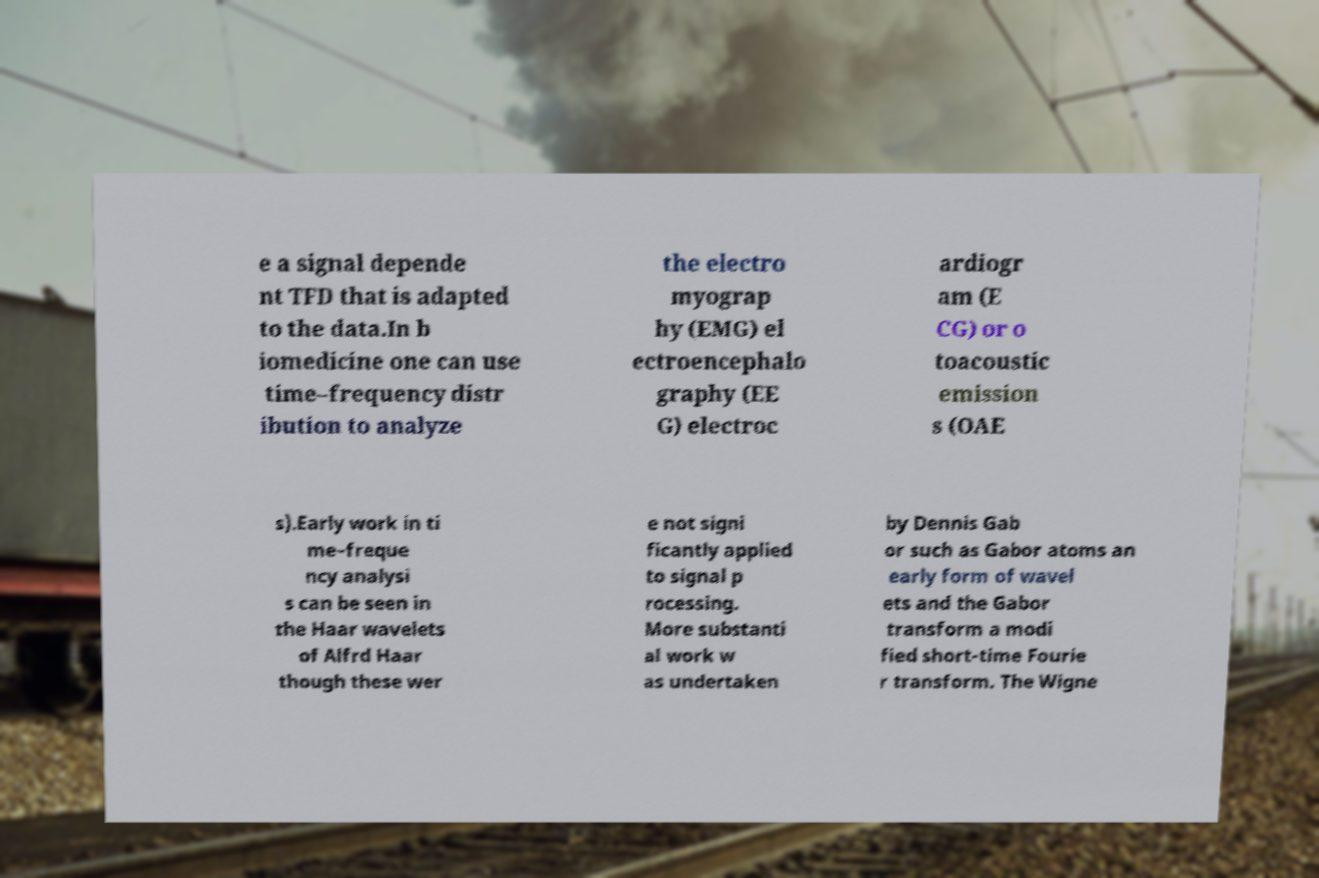There's text embedded in this image that I need extracted. Can you transcribe it verbatim? e a signal depende nt TFD that is adapted to the data.In b iomedicine one can use time–frequency distr ibution to analyze the electro myograp hy (EMG) el ectroencephalo graphy (EE G) electroc ardiogr am (E CG) or o toacoustic emission s (OAE s).Early work in ti me–freque ncy analysi s can be seen in the Haar wavelets of Alfrd Haar though these wer e not signi ficantly applied to signal p rocessing. More substanti al work w as undertaken by Dennis Gab or such as Gabor atoms an early form of wavel ets and the Gabor transform a modi fied short-time Fourie r transform. The Wigne 